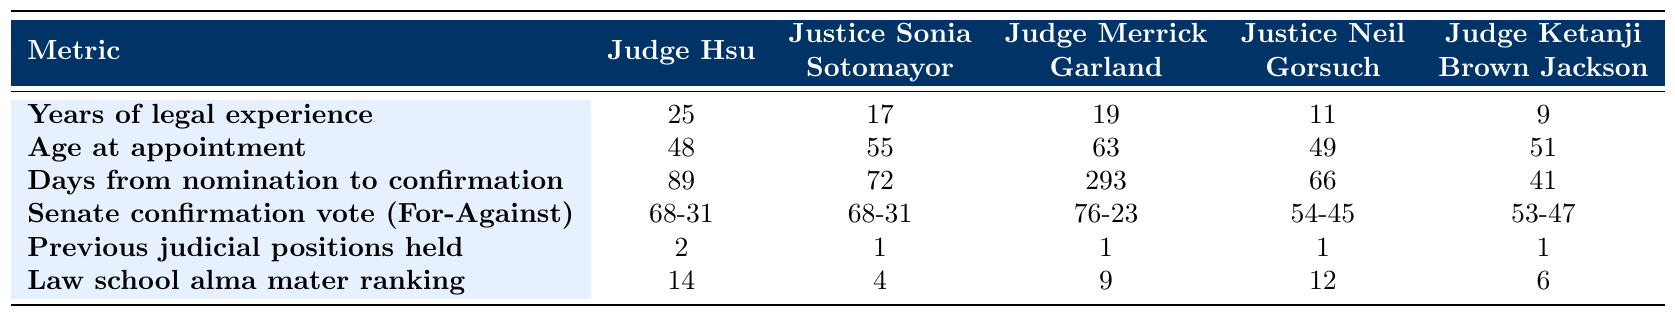What is the age of Judge Hsu at appointment? In the table, the metric for "Age at appointment" for Judge Hsu is listed as 48.
Answer: 48 Which judge had the longest time from nomination to confirmation? By comparing the "Days from nomination to confirmation" values, Judge Merrick Garland had the longest time with 293 days.
Answer: Judge Merrick Garland How many previous judicial positions did Judge Hsu hold? The metric "Previous judicial positions held" for Judge Hsu lists 2, indicating that he held two prior judicial roles.
Answer: 2 What is the Senate confirmation vote for Justice Sonia Sotomayor? The table shows that Justice Sonia Sotomayor's Senate confirmation vote is 68-31.
Answer: 68-31 Who had the least legal experience before their appointment? Comparing the "Years of legal experience before appointment," Judge Ketanji Brown Jackson had the least experience with 9 years.
Answer: Judge Ketanji Brown Jackson What is the average age at appointment for the judges listed? To find the average age at appointment, sum the ages (48 + 55 + 63 + 49 + 51 = 266) and divide by the number of judges (5), resulting in an average of 53.2.
Answer: 53.2 Did any judge have a Senate confirmation vote of 54-45? The table shows that Justice Neil Gorsuch had a Senate confirmation vote of 54-45, confirming that this is true.
Answer: Yes Which judge has the highest law school alma mater ranking? The law school alma mater rankings indicate that Justice Sonia Sotomayor has the highest ranking at 4.
Answer: Justice Sonia Sotomayor How many days prior to confirmation did Judge Hsu have compared to Judge Ketanji Brown Jackson? Judge Hsu had 89 days and Judge Ketanji Brown Jackson had 41 days, so the difference is 89 - 41 = 48 days.
Answer: 48 days If we consider all the judges, what is the median age at appointment? Listing the ages (48, 55, 63, 49, 51), when sorted (48, 49, 51, 55, 63), the median age is the middle value, which is 51.
Answer: 51 